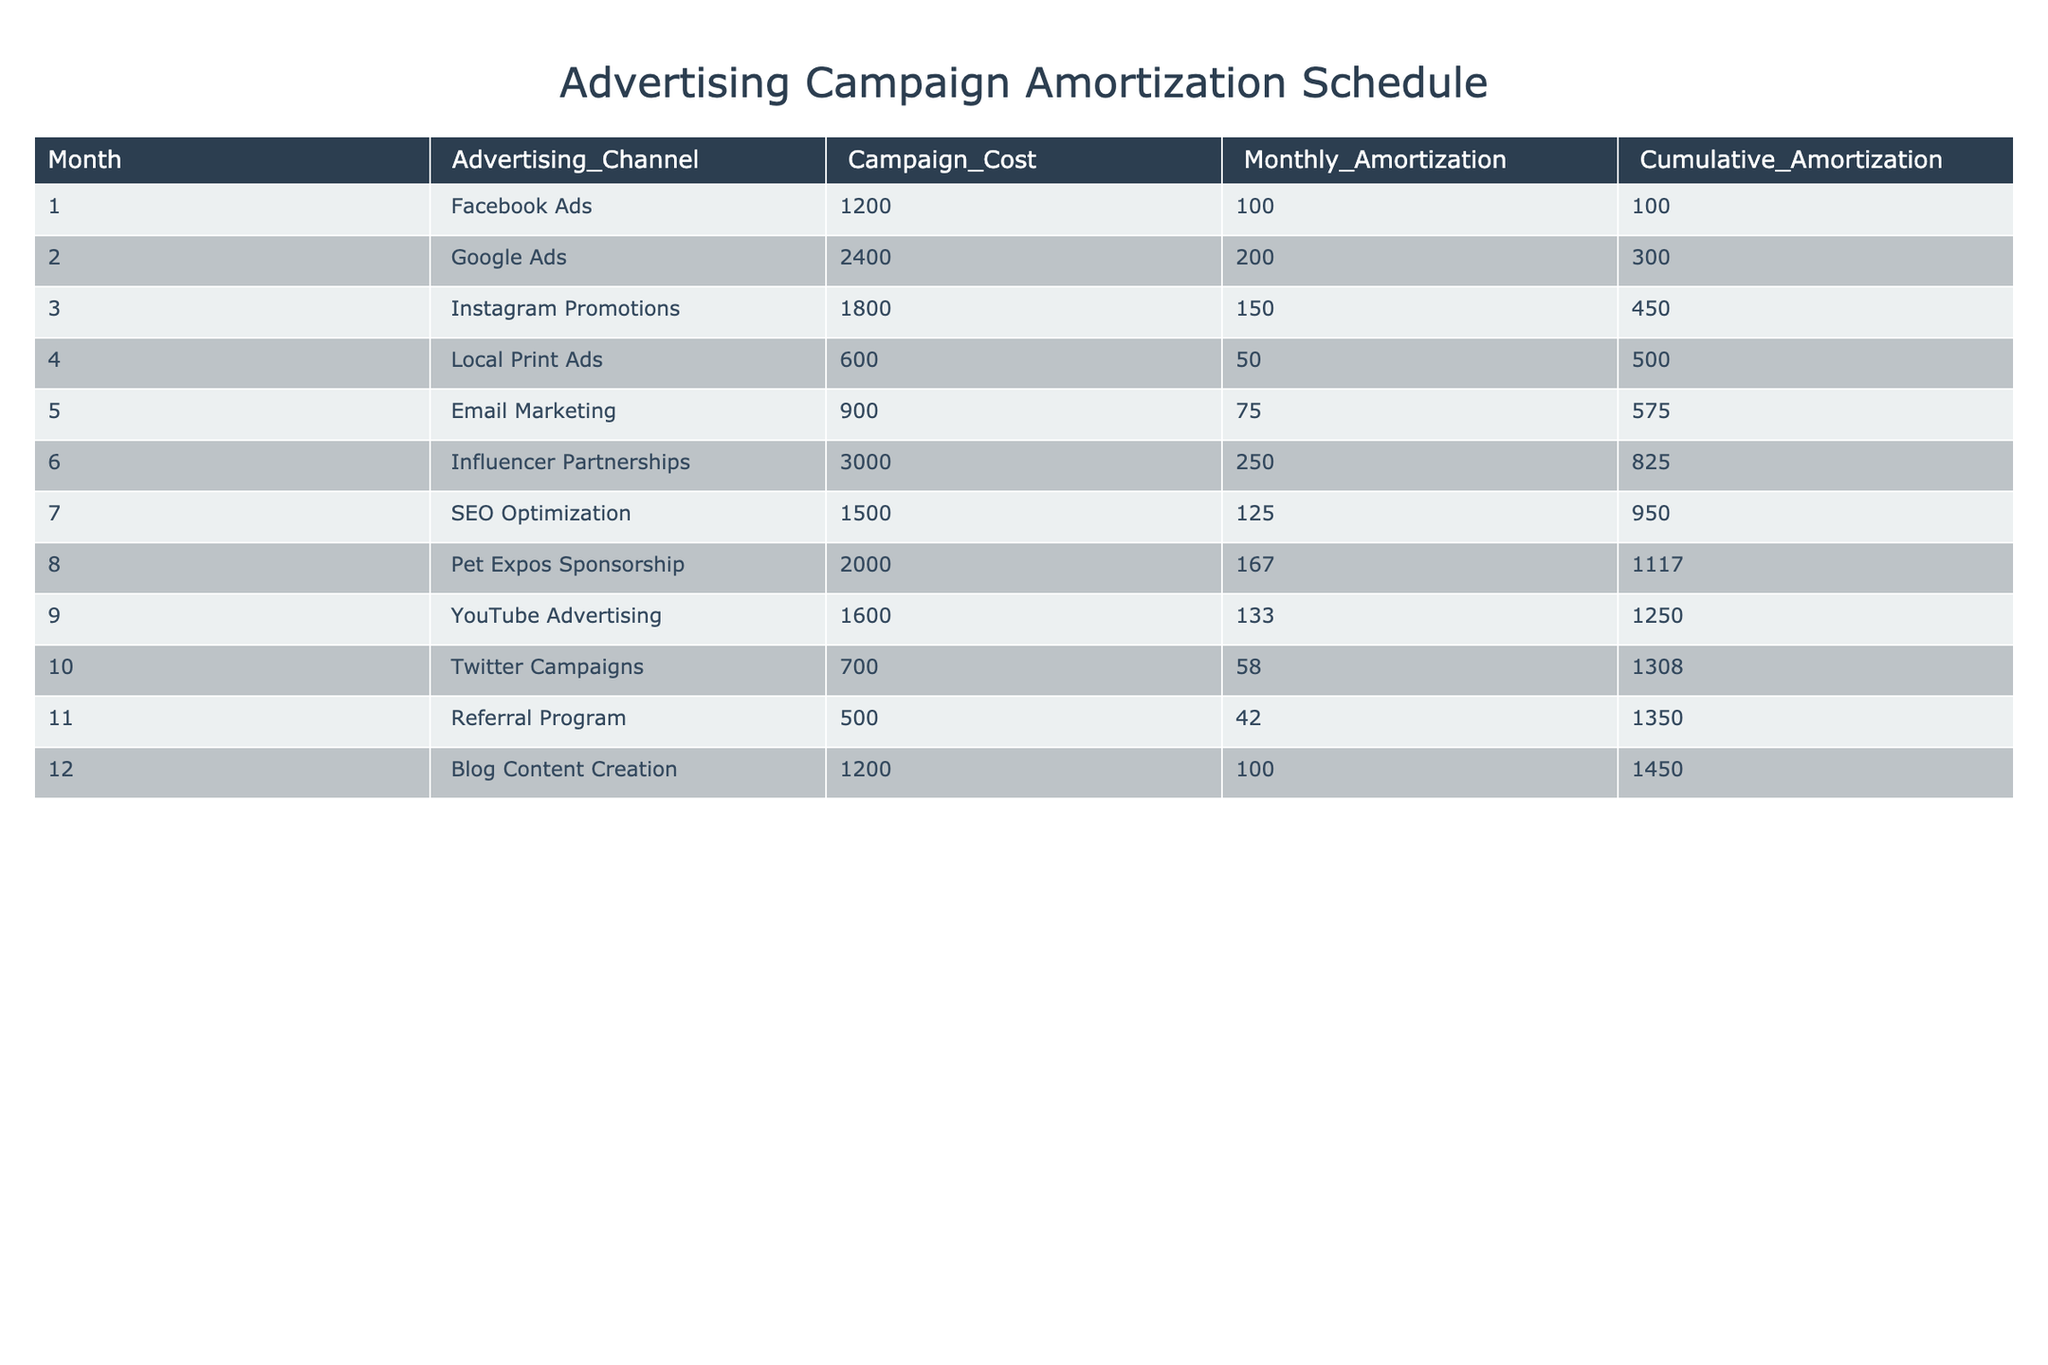What is the total advertising cost for the Facebook Ads campaign? The table shows that the advertising cost for the Facebook Ads campaign in month 1 is 1200. Since there is only one entry for Facebook Ads, the total cost is simply the amount listed.
Answer: 1200 Which advertising channel incurred the highest monthly amortization cost? The monthly amortization costs for each channel are listed: Facebook Ads (100), Google Ads (200), Instagram Promotions (150), Local Print Ads (50), Email Marketing (75), Influencer Partnerships (250), SEO Optimization (125), Pet Expos Sponsorship (167), YouTube Advertising (133), Twitter Campaigns (58), Referral Program (42), and Blog Content Creation (100). The highest value is 250 for Influencer Partnerships.
Answer: Influencer Partnerships What is the cumulative amortization cost after the sixth month? To find the cumulative amortization cost after six months, we can look at the "Cumulative_Amortization" column for month 6, which shows a cumulative amortization of 825.
Answer: 825 How much more was spent on Google Ads compared to Local Print Ads? The cost for Google Ads is 2400 and the cost for Local Print Ads is 600. The difference is calculated as 2400 - 600 = 1800.
Answer: 1800 Is the monthly amortization for the Referral Program greater than the monthly amortization for the Email Marketing campaign? The monthly amortization for the Referral Program is listed as 42 while for Email Marketing it is 75. Since 42 is less than 75, the statement is false.
Answer: No What is the average monthly amortization cost across all advertising channels? We sum the monthly amortization costs: 100 + 200 + 150 + 50 + 75 + 250 + 125 + 167 + 133 + 58 + 42 + 100 = 1420. There are 12 months, so the average is 1420 / 12 = 118.33.
Answer: 118.33 What is the cumulative amortization amount for the Instagram Promotions by month 3? The cumulative amortization after three months can be found in the fourth row of the table, which shows 450 after month 3 (the cumulative values add up through each month).
Answer: 450 Which advertising campaign had the lowest cumulative amortization at the end of the table? Looking at the cumulative amortization amounts for the final month (12), the lowest amount shown is 500 for Local Print Ads.
Answer: Local Print Ads 